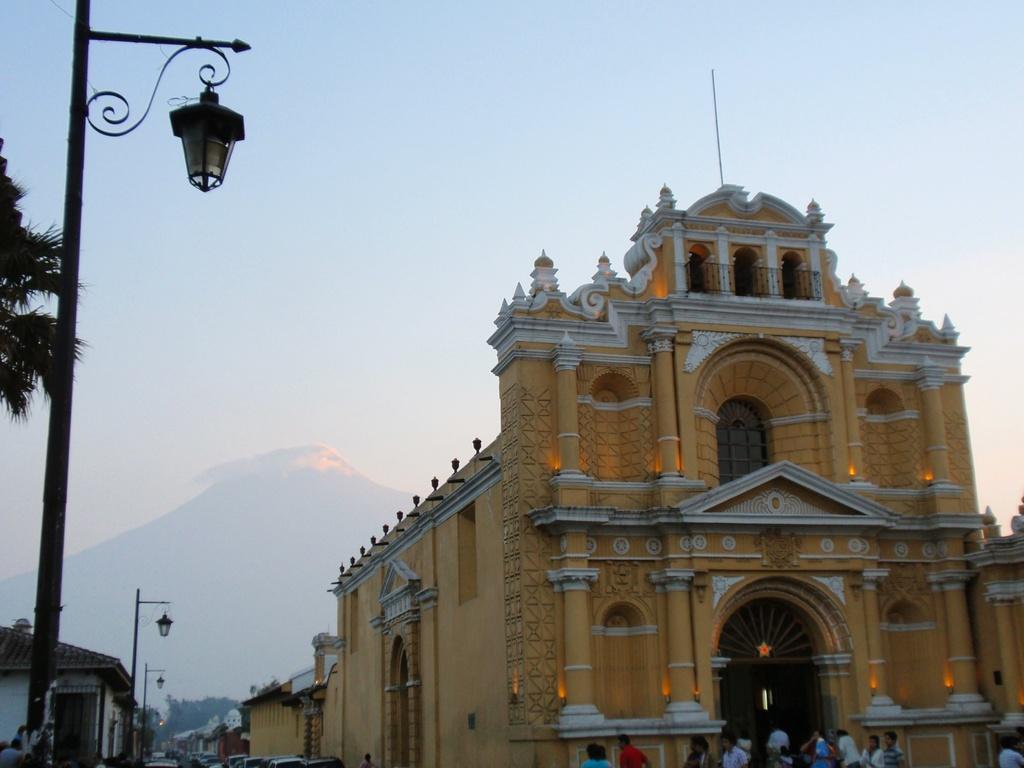Could you give a brief overview of what you see in this image? On the left there are street lights, trees and buildings. In the center of the picture there are buildings and people. In the background there is a mountain. 